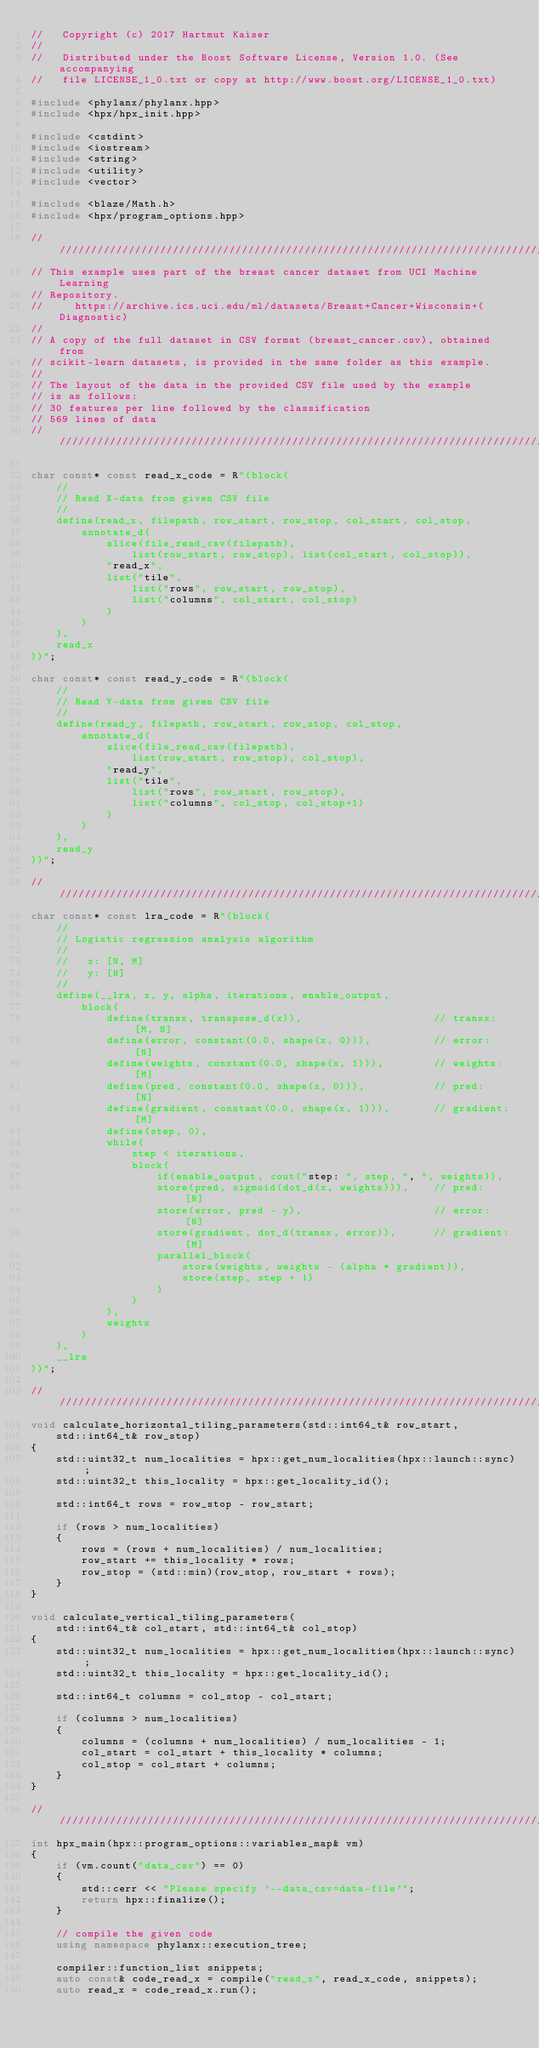<code> <loc_0><loc_0><loc_500><loc_500><_C++_>//   Copyright (c) 2017 Hartmut Kaiser
//
//   Distributed under the Boost Software License, Version 1.0. (See accompanying
//   file LICENSE_1_0.txt or copy at http://www.boost.org/LICENSE_1_0.txt)

#include <phylanx/phylanx.hpp>
#include <hpx/hpx_init.hpp>

#include <cstdint>
#include <iostream>
#include <string>
#include <utility>
#include <vector>

#include <blaze/Math.h>
#include <hpx/program_options.hpp>

//////////////////////////////////////////////////////////////////////////////////
// This example uses part of the breast cancer dataset from UCI Machine Learning
// Repository.
//     https://archive.ics.uci.edu/ml/datasets/Breast+Cancer+Wisconsin+(Diagnostic)
//
// A copy of the full dataset in CSV format (breast_cancer.csv), obtained from
// scikit-learn datasets, is provided in the same folder as this example.
//
// The layout of the data in the provided CSV file used by the example
// is as follows:
// 30 features per line followed by the classification
// 569 lines of data
/////////////////////////////////////////////////////////////////////////////////

char const* const read_x_code = R"(block(
    //
    // Read X-data from given CSV file
    //
    define(read_x, filepath, row_start, row_stop, col_start, col_stop,
        annotate_d(
            slice(file_read_csv(filepath),
                list(row_start, row_stop), list(col_start, col_stop)),
            "read_x",
            list("tile",
                list("rows", row_start, row_stop),
                list("columns", col_start, col_stop)
            )
        )
    ),
    read_x
))";

char const* const read_y_code = R"(block(
    //
    // Read Y-data from given CSV file
    //
    define(read_y, filepath, row_start, row_stop, col_stop,
        annotate_d(
            slice(file_read_csv(filepath),
                list(row_start, row_stop), col_stop),
            "read_y",
            list("tile",
                list("rows", row_start, row_stop),
                list("columns", col_stop, col_stop+1)
            )
        )
    ),
    read_y
))";

///////////////////////////////////////////////////////////////////////////////
char const* const lra_code = R"(block(
    //
    // Logistic regression analysis algorithm
    //
    //   x: [N, M]
    //   y: [N]
    //
    define(__lra, x, y, alpha, iterations, enable_output,
        block(
            define(transx, transpose_d(x)),                     // transx:   [M, N]
            define(error, constant(0.0, shape(x, 0))),          // error:    [N]
            define(weights, constant(0.0, shape(x, 1))),        // weights:  [M]
            define(pred, constant(0.0, shape(x, 0))),           // pred:     [N]
            define(gradient, constant(0.0, shape(x, 1))),       // gradient: [M]
            define(step, 0),
            while(
                step < iterations,
                block(
                    if(enable_output, cout("step: ", step, ", ", weights)),
                    store(pred, sigmoid(dot_d(x, weights))),    // pred:     [N]
                    store(error, pred - y),                     // error:    [N]
                    store(gradient, dot_d(transx, error)),      // gradient: [M]
                    parallel_block(
                        store(weights, weights - (alpha * gradient)),
                        store(step, step + 1)
                    )
                )
            ),
            weights
        )
    ),
    __lra
))";

////////////////////////////////////////////////////////////////////////////////
void calculate_horizontal_tiling_parameters(std::int64_t& row_start,
    std::int64_t& row_stop)
{
    std::uint32_t num_localities = hpx::get_num_localities(hpx::launch::sync);
    std::uint32_t this_locality = hpx::get_locality_id();

    std::int64_t rows = row_stop - row_start;

    if (rows > num_localities)
    {
        rows = (rows + num_localities) / num_localities;
        row_start += this_locality * rows;
        row_stop = (std::min)(row_stop, row_start + rows);
    }
}

void calculate_vertical_tiling_parameters(
    std::int64_t& col_start, std::int64_t& col_stop)
{
    std::uint32_t num_localities = hpx::get_num_localities(hpx::launch::sync);
    std::uint32_t this_locality = hpx::get_locality_id();

    std::int64_t columns = col_stop - col_start;

    if (columns > num_localities)
    {
        columns = (columns + num_localities) / num_localities - 1;
        col_start = col_start + this_locality * columns;
        col_stop = col_start + columns;
    }
}

////////////////////////////////////////////////////////////////////////////////
int hpx_main(hpx::program_options::variables_map& vm)
{
    if (vm.count("data_csv") == 0)
    {
        std::cerr << "Please specify '--data_csv=data-file'";
        return hpx::finalize();
    }

    // compile the given code
    using namespace phylanx::execution_tree;

    compiler::function_list snippets;
    auto const& code_read_x = compile("read_x", read_x_code, snippets);
    auto read_x = code_read_x.run();
</code> 